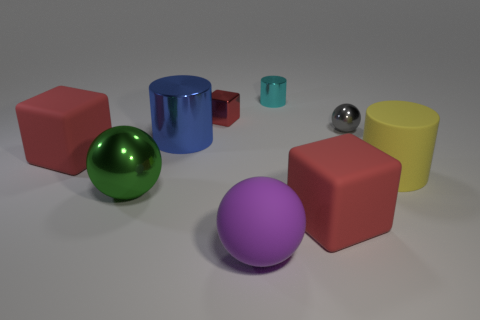What number of metallic cubes have the same size as the gray object?
Your response must be concise. 1. There is a red matte thing to the right of the large rubber sphere; is its size the same as the metallic sphere behind the yellow rubber thing?
Keep it short and to the point. No. How many objects are blue shiny cylinders or metallic things in front of the small metal block?
Offer a terse response. 3. The large shiny sphere is what color?
Your answer should be very brief. Green. What material is the large red object that is right of the big rubber cube behind the big object right of the tiny gray metal sphere?
Ensure brevity in your answer.  Rubber. There is a green object that is the same material as the cyan thing; what size is it?
Keep it short and to the point. Large. Is there a object that has the same color as the tiny metallic cube?
Ensure brevity in your answer.  Yes. Does the gray shiny sphere have the same size as the shiny cylinder behind the large blue thing?
Offer a very short reply. Yes. How many rubber cylinders are on the left side of the red thing that is in front of the matte cube behind the green metallic ball?
Ensure brevity in your answer.  0. There is a tiny gray shiny object; are there any cylinders behind it?
Provide a succinct answer. Yes. 